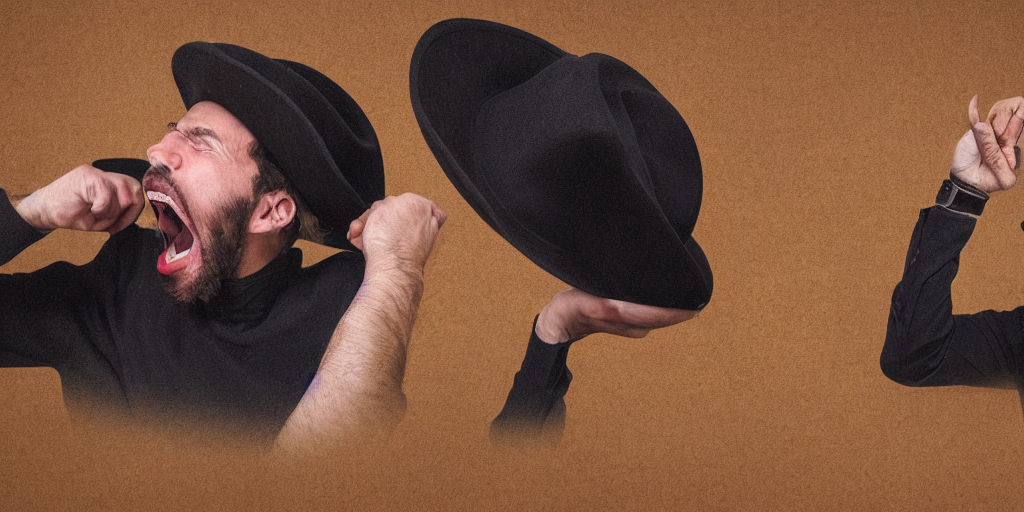Can you describe the artistic technique used in this image? Certainly! This image showcases a digital composite technique where multiple exposures or moments are merged. The aesthetic is surreal and engages the viewer with an unexpected visual twist that juxtaposes calmness with intense emotion, all while using a monochromatic color scheme to maintain coherence. 